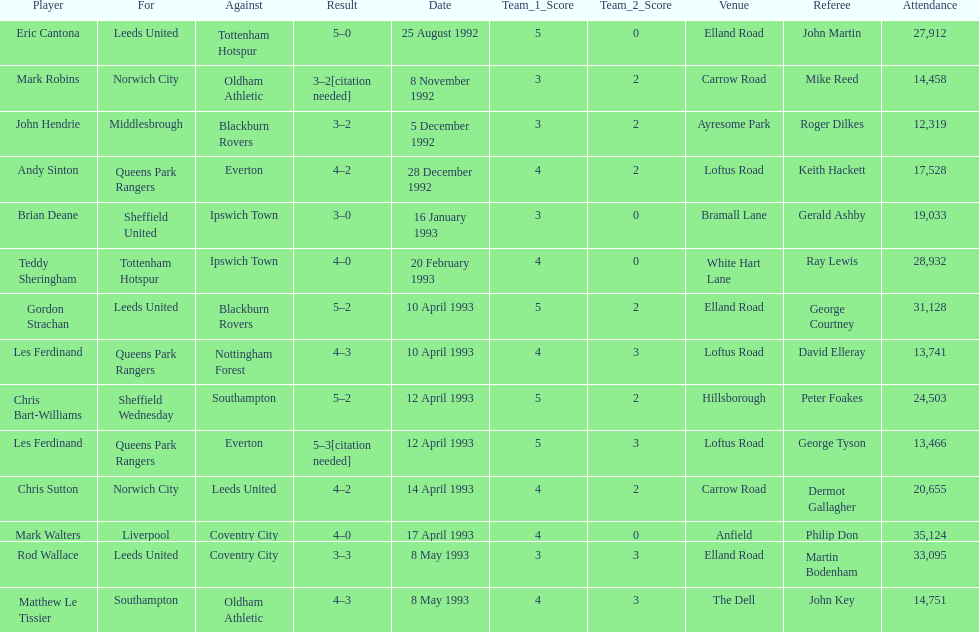Southampton played on may 8th, 1993, who was their opponent? Oldham Athletic. 